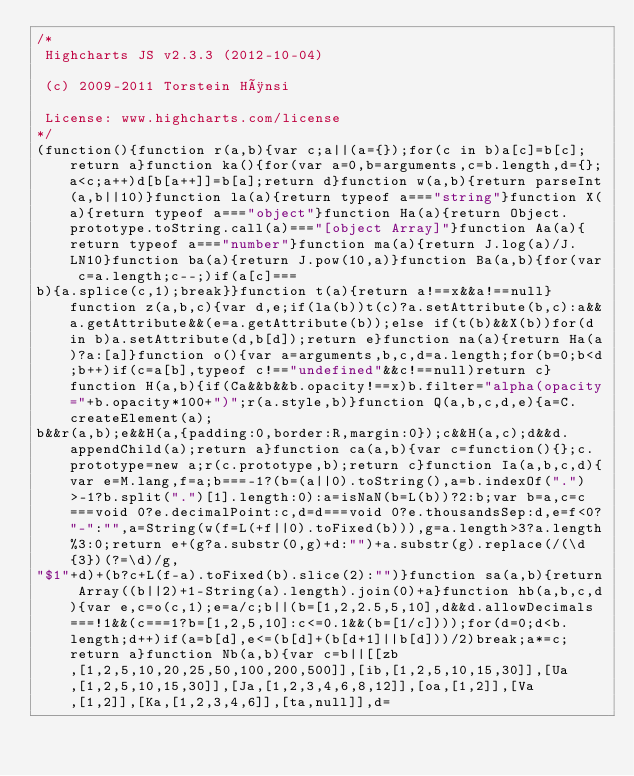Convert code to text. <code><loc_0><loc_0><loc_500><loc_500><_JavaScript_>/*
 Highcharts JS v2.3.3 (2012-10-04)

 (c) 2009-2011 Torstein Hønsi

 License: www.highcharts.com/license
*/
(function(){function r(a,b){var c;a||(a={});for(c in b)a[c]=b[c];return a}function ka(){for(var a=0,b=arguments,c=b.length,d={};a<c;a++)d[b[a++]]=b[a];return d}function w(a,b){return parseInt(a,b||10)}function la(a){return typeof a==="string"}function X(a){return typeof a==="object"}function Ha(a){return Object.prototype.toString.call(a)==="[object Array]"}function Aa(a){return typeof a==="number"}function ma(a){return J.log(a)/J.LN10}function ba(a){return J.pow(10,a)}function Ba(a,b){for(var c=a.length;c--;)if(a[c]===
b){a.splice(c,1);break}}function t(a){return a!==x&&a!==null}function z(a,b,c){var d,e;if(la(b))t(c)?a.setAttribute(b,c):a&&a.getAttribute&&(e=a.getAttribute(b));else if(t(b)&&X(b))for(d in b)a.setAttribute(d,b[d]);return e}function na(a){return Ha(a)?a:[a]}function o(){var a=arguments,b,c,d=a.length;for(b=0;b<d;b++)if(c=a[b],typeof c!=="undefined"&&c!==null)return c}function H(a,b){if(Ca&&b&&b.opacity!==x)b.filter="alpha(opacity="+b.opacity*100+")";r(a.style,b)}function Q(a,b,c,d,e){a=C.createElement(a);
b&&r(a,b);e&&H(a,{padding:0,border:R,margin:0});c&&H(a,c);d&&d.appendChild(a);return a}function ca(a,b){var c=function(){};c.prototype=new a;r(c.prototype,b);return c}function Ia(a,b,c,d){var e=M.lang,f=a;b===-1?(b=(a||0).toString(),a=b.indexOf(".")>-1?b.split(".")[1].length:0):a=isNaN(b=L(b))?2:b;var b=a,c=c===void 0?e.decimalPoint:c,d=d===void 0?e.thousandsSep:d,e=f<0?"-":"",a=String(w(f=L(+f||0).toFixed(b))),g=a.length>3?a.length%3:0;return e+(g?a.substr(0,g)+d:"")+a.substr(g).replace(/(\d{3})(?=\d)/g,
"$1"+d)+(b?c+L(f-a).toFixed(b).slice(2):"")}function sa(a,b){return Array((b||2)+1-String(a).length).join(0)+a}function hb(a,b,c,d){var e,c=o(c,1);e=a/c;b||(b=[1,2,2.5,5,10],d&&d.allowDecimals===!1&&(c===1?b=[1,2,5,10]:c<=0.1&&(b=[1/c])));for(d=0;d<b.length;d++)if(a=b[d],e<=(b[d]+(b[d+1]||b[d]))/2)break;a*=c;return a}function Nb(a,b){var c=b||[[zb,[1,2,5,10,20,25,50,100,200,500]],[ib,[1,2,5,10,15,30]],[Ua,[1,2,5,10,15,30]],[Ja,[1,2,3,4,6,8,12]],[oa,[1,2]],[Va,[1,2]],[Ka,[1,2,3,4,6]],[ta,null]],d=</code> 